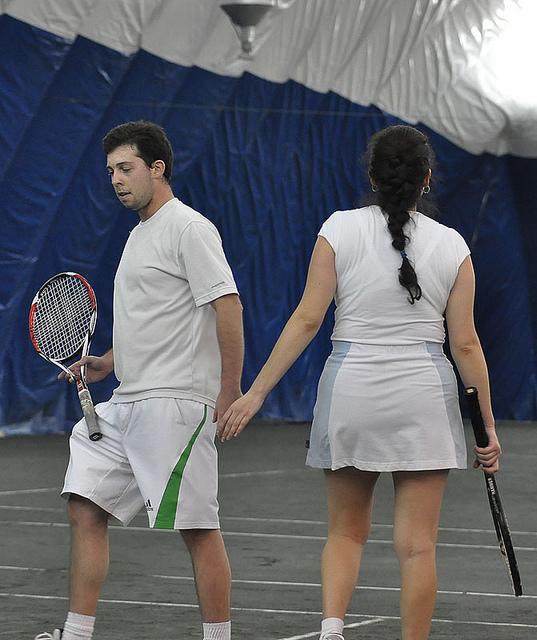How many men in the picture?
Write a very short answer. 1. Which sports is this?
Give a very brief answer. Tennis. What color is the tennis racket that female is holding?
Write a very short answer. Black. 